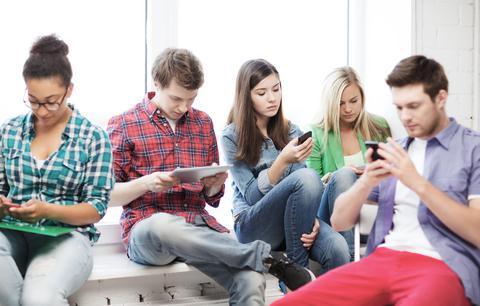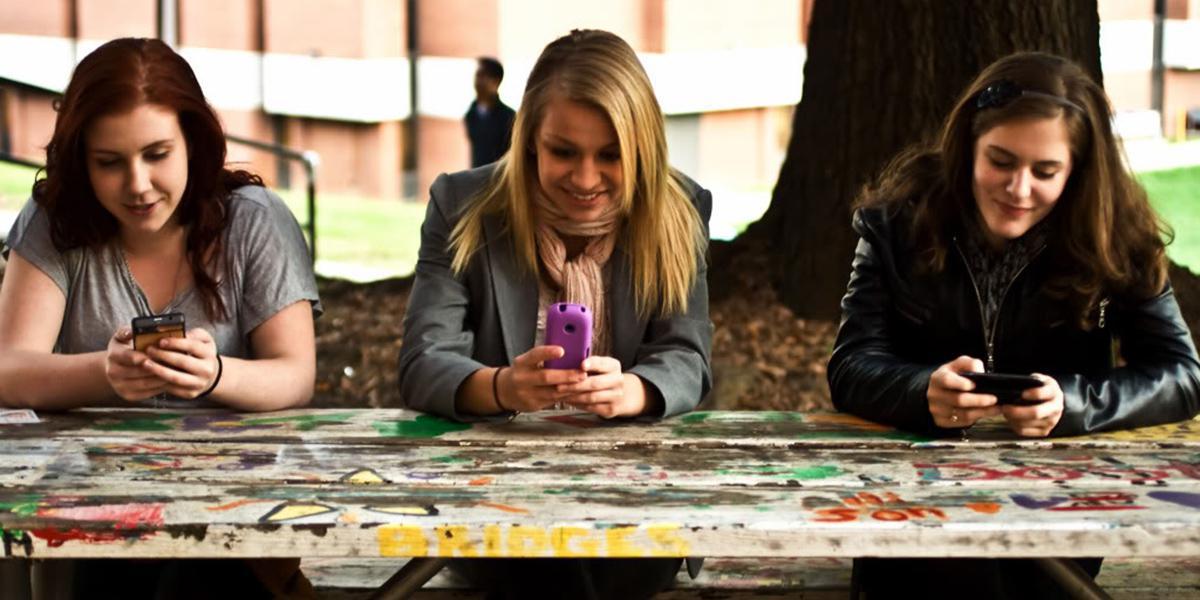The first image is the image on the left, the second image is the image on the right. Considering the images on both sides, is "Three people are sitting together looking at their phones in the image on the right." valid? Answer yes or no. Yes. The first image is the image on the left, the second image is the image on the right. Evaluate the accuracy of this statement regarding the images: "there are three people sitting at a shiny brown table looking at their phones, there are two men on the outside and a woman in the center". Is it true? Answer yes or no. No. 